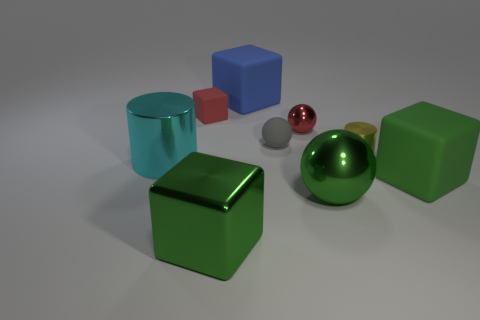There is a large rubber block behind the metallic cylinder that is to the left of the small cylinder; what number of small red rubber blocks are in front of it?
Offer a terse response. 1. How many things are there?
Provide a short and direct response. 9. Is the number of tiny metallic things that are behind the gray sphere less than the number of small red objects that are to the right of the blue thing?
Your answer should be compact. No. Is the number of blue objects that are on the right side of the tiny cylinder less than the number of metallic cubes?
Your response must be concise. Yes. There is a green thing left of the tiny matte object that is in front of the matte block that is to the left of the blue matte block; what is its material?
Keep it short and to the point. Metal. How many objects are either green objects that are left of the small metal ball or rubber blocks that are to the left of the small gray ball?
Ensure brevity in your answer.  3. There is a large object that is the same shape as the small gray thing; what is it made of?
Give a very brief answer. Metal. What number of shiny objects are cyan cylinders or green objects?
Provide a short and direct response. 3. The small thing that is made of the same material as the yellow cylinder is what shape?
Your response must be concise. Sphere. What number of blue things are the same shape as the tiny red matte thing?
Ensure brevity in your answer.  1. 